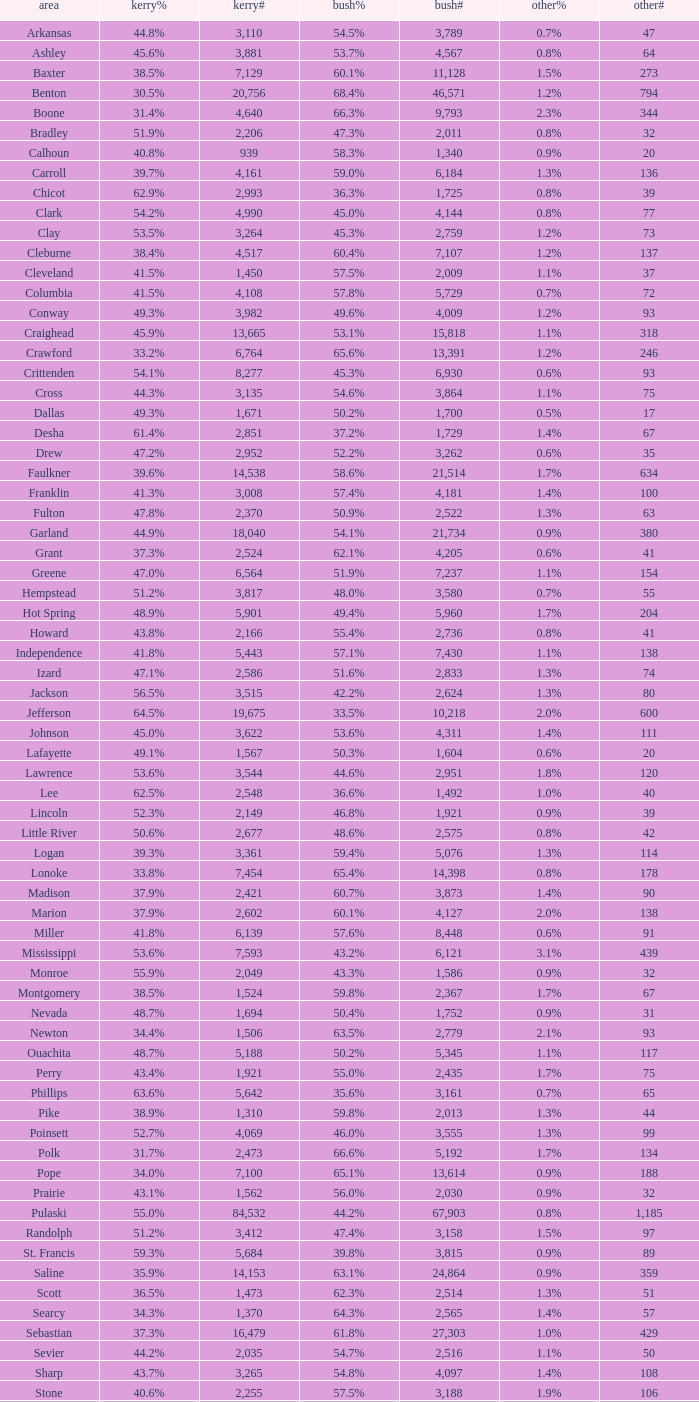When others# equals "106" and bush# is under 3,188, what is the smallest possible kerry#? None. 